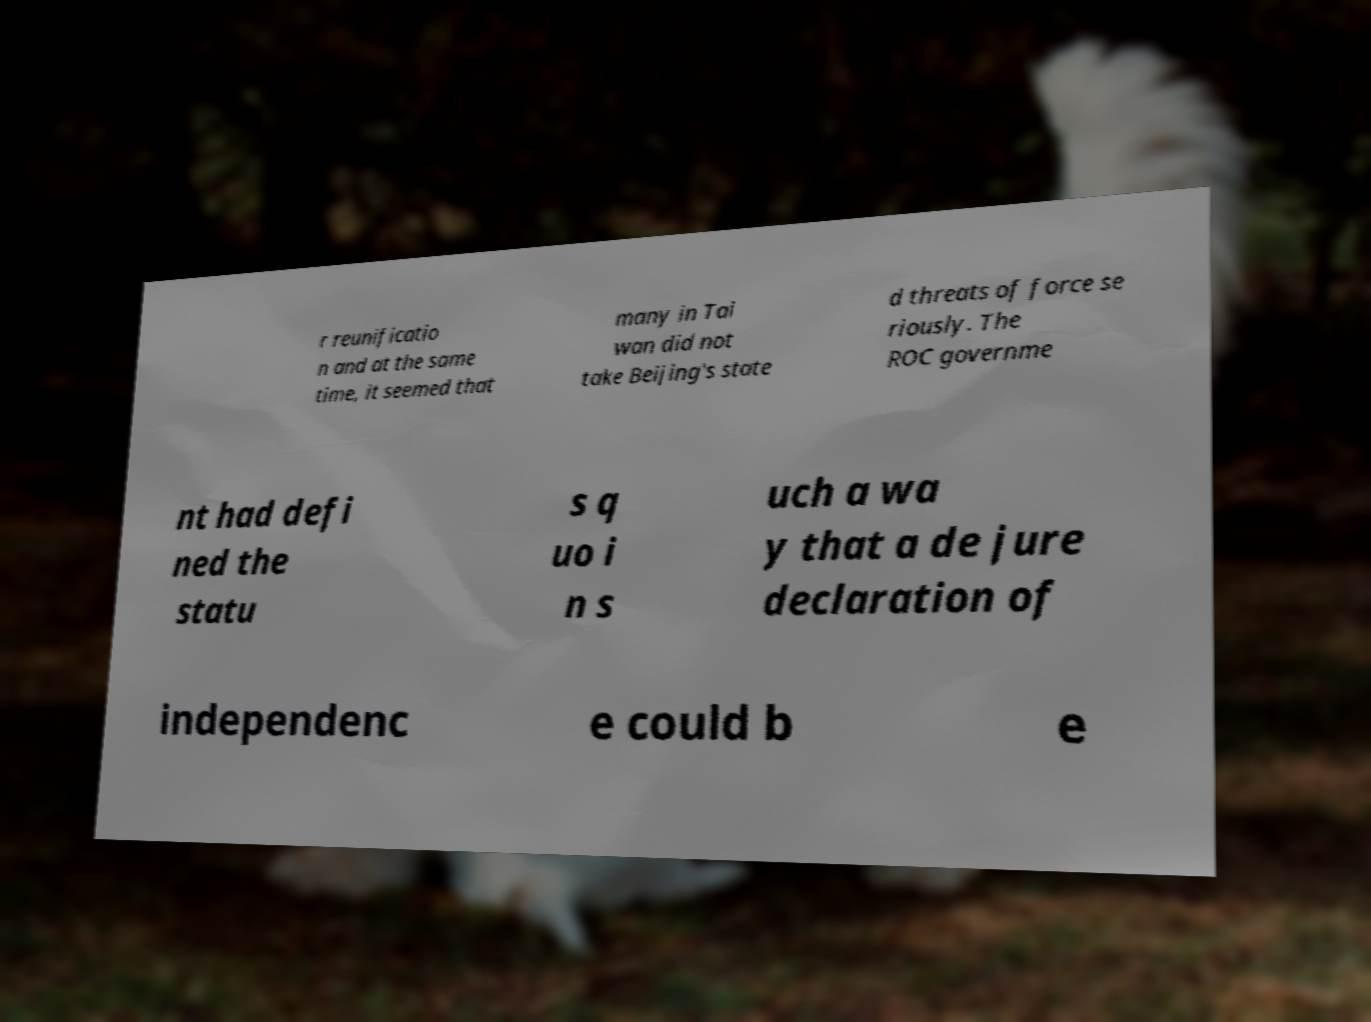I need the written content from this picture converted into text. Can you do that? r reunificatio n and at the same time, it seemed that many in Tai wan did not take Beijing's state d threats of force se riously. The ROC governme nt had defi ned the statu s q uo i n s uch a wa y that a de jure declaration of independenc e could b e 